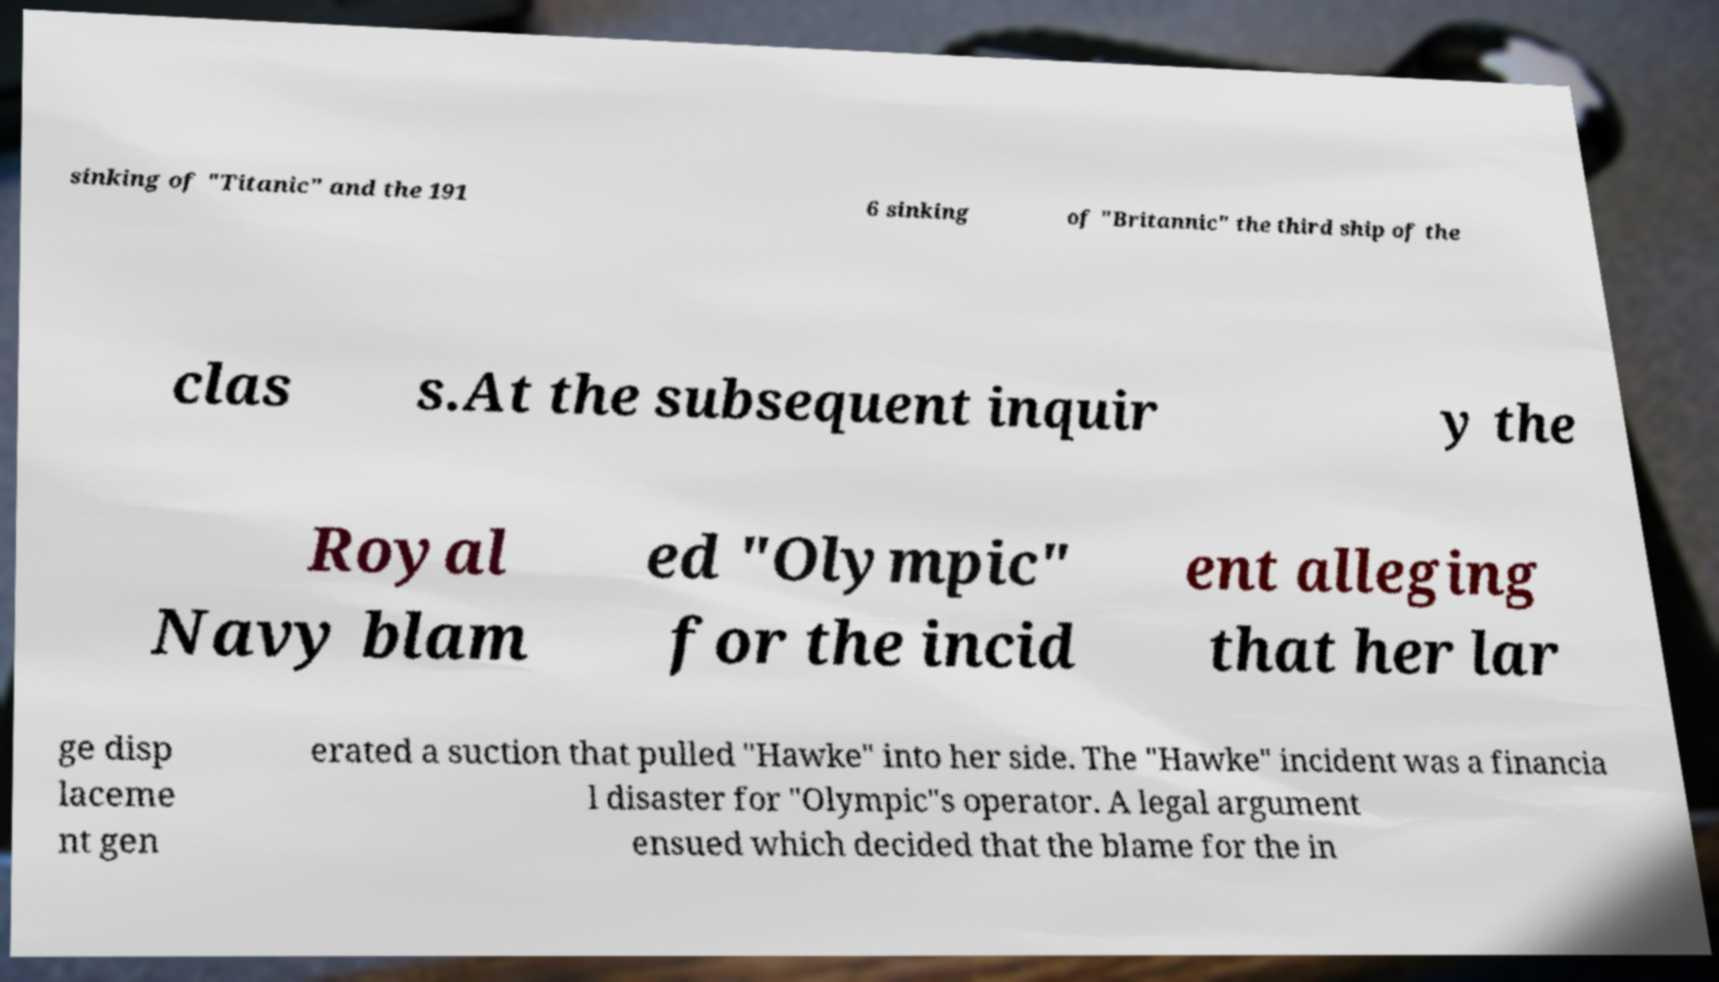For documentation purposes, I need the text within this image transcribed. Could you provide that? sinking of "Titanic" and the 191 6 sinking of "Britannic" the third ship of the clas s.At the subsequent inquir y the Royal Navy blam ed "Olympic" for the incid ent alleging that her lar ge disp laceme nt gen erated a suction that pulled "Hawke" into her side. The "Hawke" incident was a financia l disaster for "Olympic"s operator. A legal argument ensued which decided that the blame for the in 